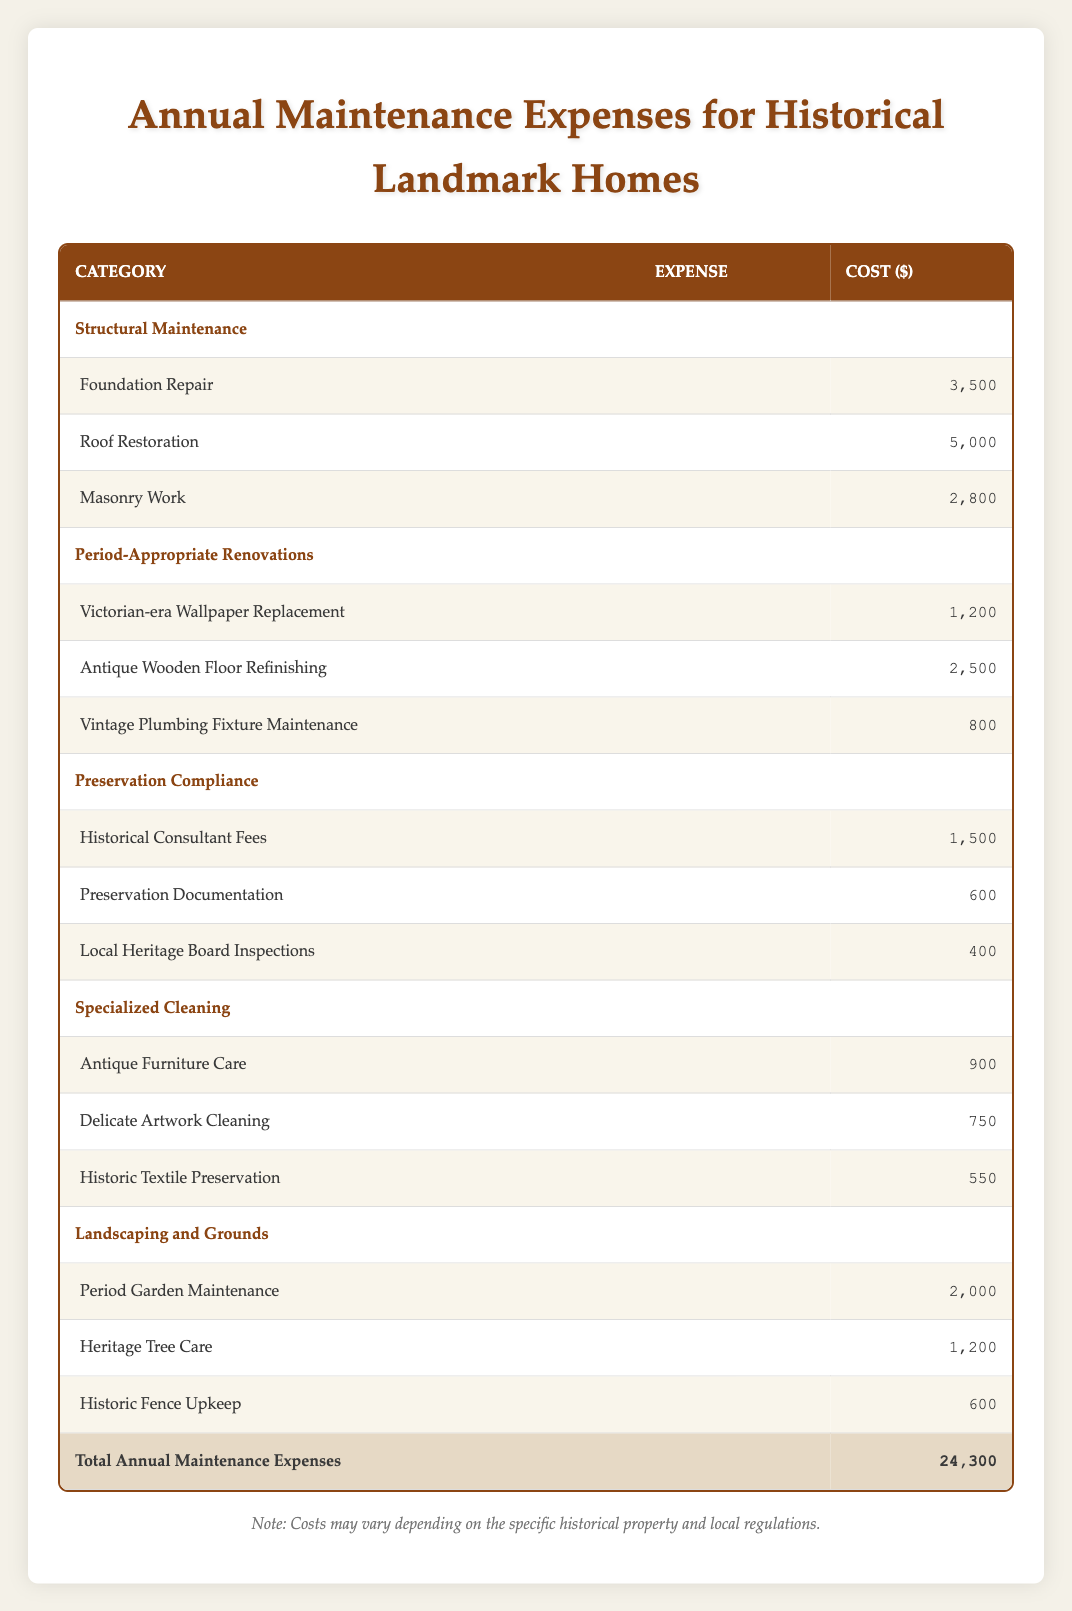What are the total costs for Structural Maintenance? The total costs for Structural Maintenance can be calculated by adding the individual costs of its subcategories. These are: Foundation Repair (3,500) + Roof Restoration (5,000) + Masonry Work (2,800). Adding these gives 3,500 + 5,000 + 2,800 = 11,300.
Answer: 11,300 Which category has the highest single expense? To determine which category has the highest single expense, we need to compare the costs of all subcategories. The highest amounts are from Roof Restoration (5,000), Antique Wooden Floor Refinishing (2,500), and Foundation Repair (3,500). Clearly, Roof Restoration at 5,000 is the highest single expense.
Answer: Roof Restoration Is the total annual maintenance expense above or below 25,000? The total annual maintenance expense is listed as 24,300. This is below 25,000.
Answer: Below What is the total cost for Preservation Compliance? The total cost for Preservation Compliance is determined by adding the costs of its subcategories: Historical Consultant Fees (1,500) + Preservation Documentation (600) + Local Heritage Board Inspections (400) equals 1,500 + 600 + 400 = 2,500.
Answer: 2,500 How much more does Structural Maintenance cost than Specialized Cleaning? To find out how much more Structural Maintenance costs than Specialized Cleaning, we first find their totals: Structural Maintenance is 11,300 and Specialized Cleaning is 2,200 (Antique Furniture Care: 900 + Delicate Artwork Cleaning: 750 + Historic Textile Preservation: 550). The difference is 11,300 - 2,200 = 9,100.
Answer: 9,100 Are the costs of Landscaping and Grounds higher than Specialized Cleaning? The total costs for Landscaping and Grounds is 3,800 (Period Garden Maintenance: 2,000 + Heritage Tree Care: 1,200 + Historic Fence Upkeep: 600). Specialized Cleaning totals 2,200. Since 3,800 is higher than 2,200, it's correct to say that Landscaping and Grounds costs more.
Answer: Yes What is the average cost of all subcategories in Period-Appropriate Renovations? To find the average cost in Period-Appropriate Renovations, we add the costs of all three subcategories: Victorian-era Wallpaper Replacement (1,200) + Antique Wooden Floor Refinishing (2,500) + Vintage Plumbing Fixture Maintenance (800) gives a total of 4,500. There are 3 subcategories, so we calculate the average: 4,500 / 3 = 1,500.
Answer: 1,500 Which category has the lowest total expense? The lowest total expense is calculated by summing each category's subtotals: Structural Maintenance (11,300), Period-Appropriate Renovations (4,500), Preservation Compliance (2,500), Specialized Cleaning (2,200), and Landscaping and Grounds (3,800). The lowest among these is Specialized Cleaning at 2,200.
Answer: Specialized Cleaning 